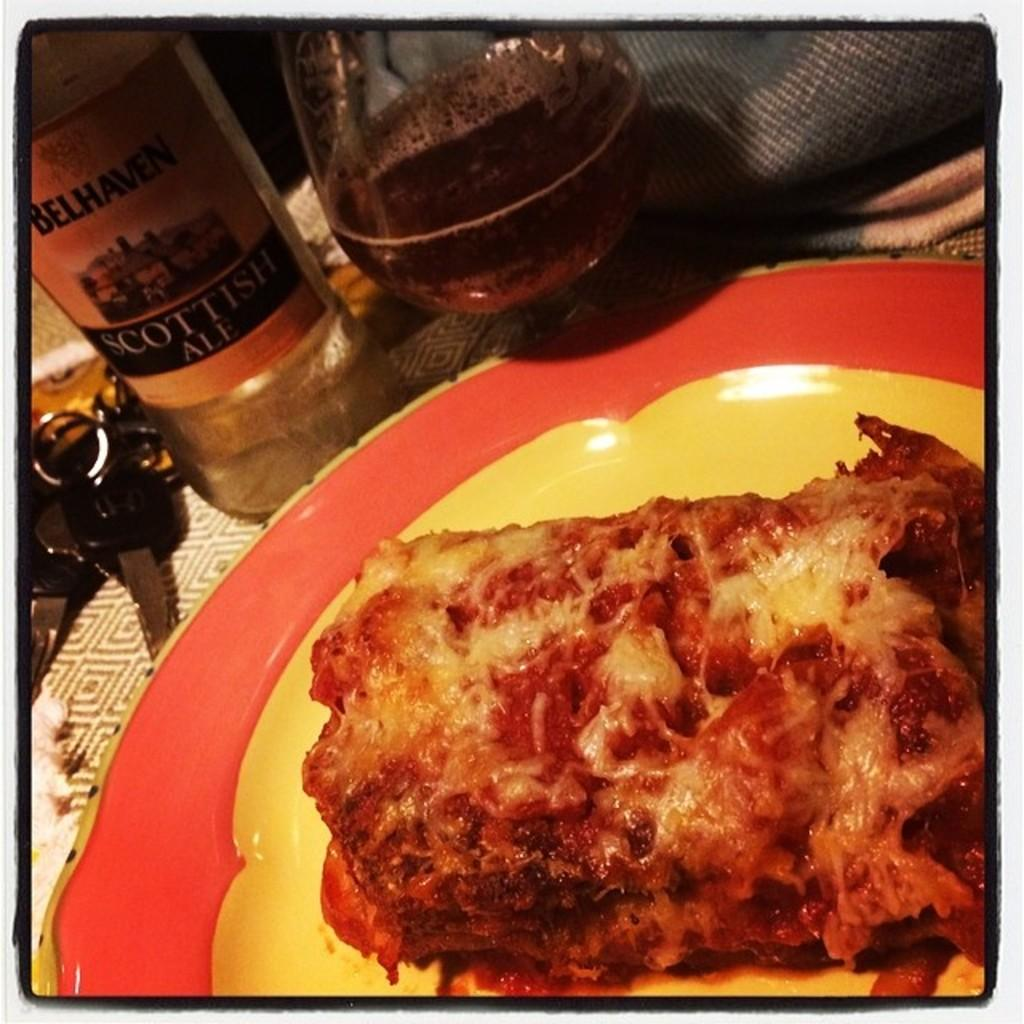<image>
Render a clear and concise summary of the photo. a bottle of Scottish Ale is behind a plate of lasagne 